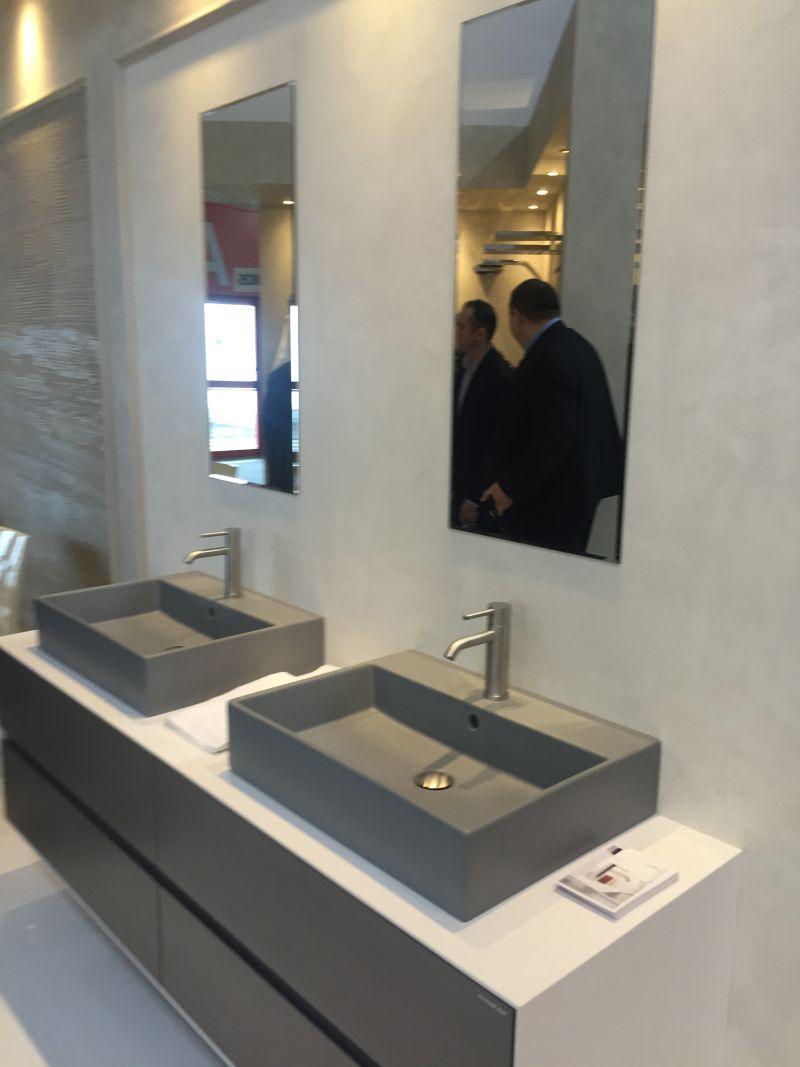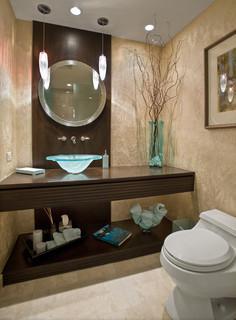The first image is the image on the left, the second image is the image on the right. Considering the images on both sides, is "There are two sinks in the image on the left." valid? Answer yes or no. Yes. The first image is the image on the left, the second image is the image on the right. Examine the images to the left and right. Is the description "One image shows a round mirror above a vessel sink on a vanity counter." accurate? Answer yes or no. Yes. 